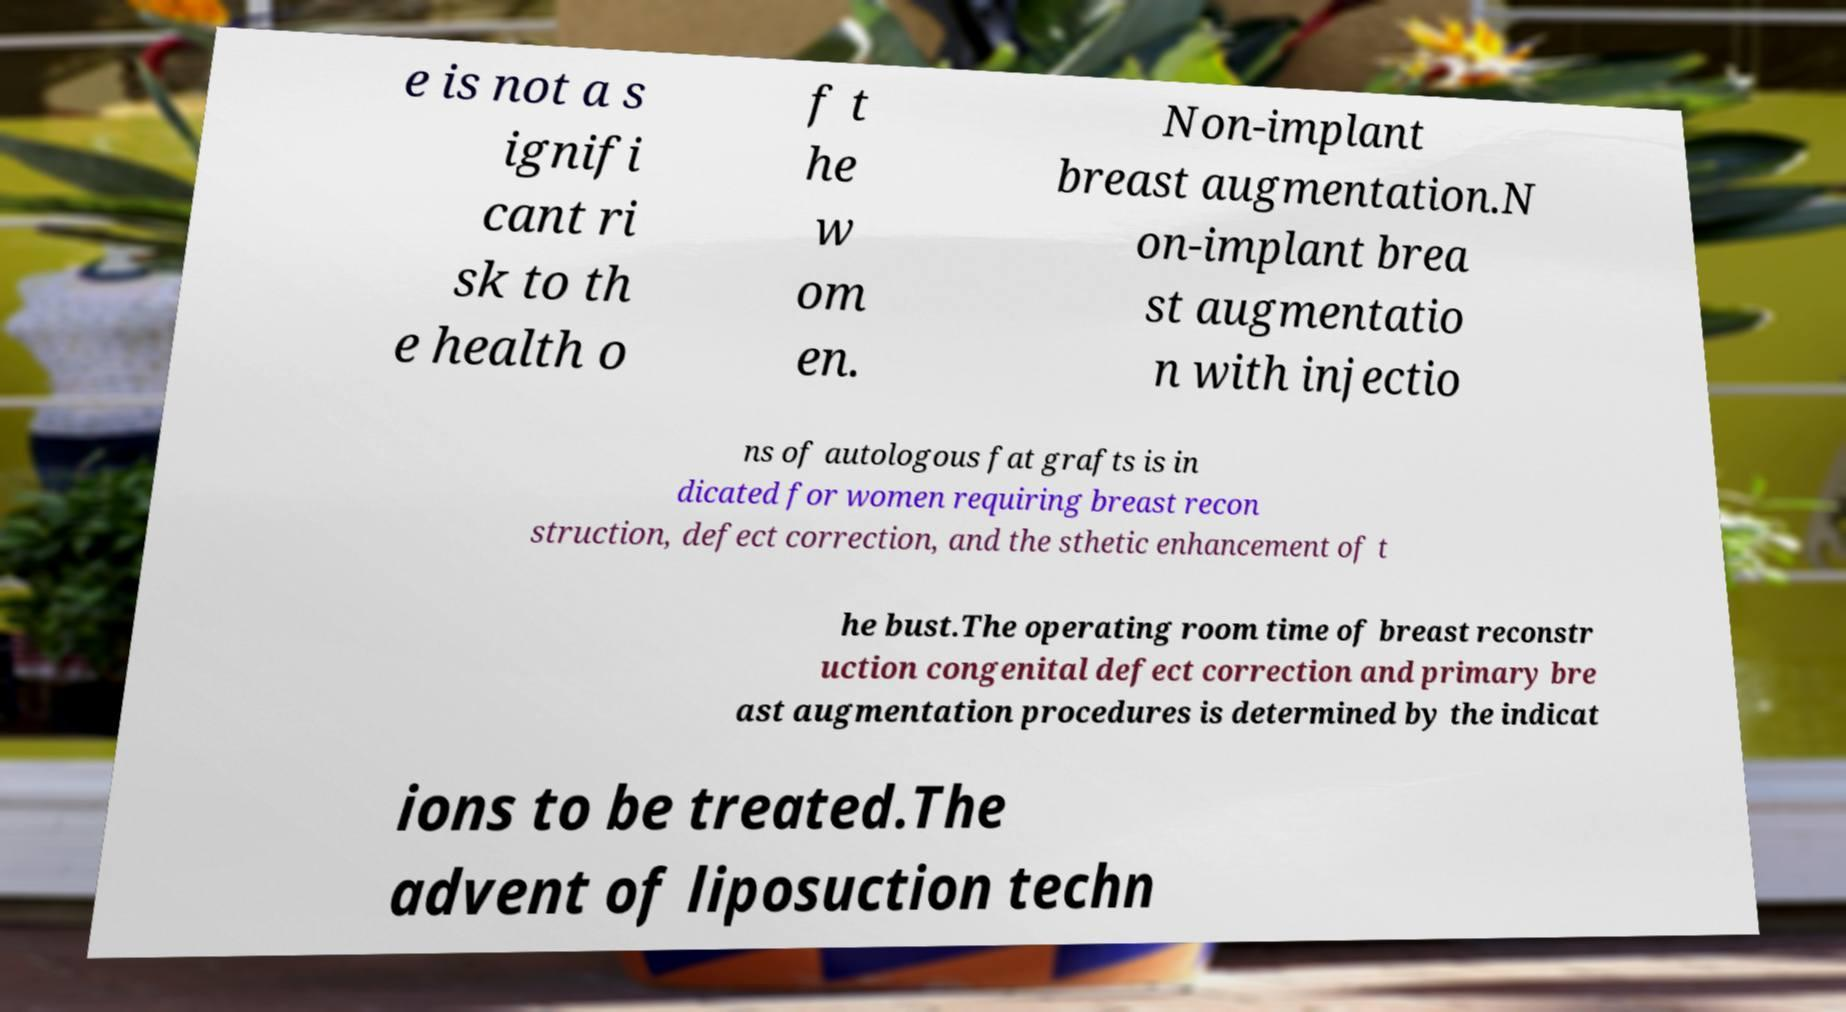What messages or text are displayed in this image? I need them in a readable, typed format. e is not a s ignifi cant ri sk to th e health o f t he w om en. Non-implant breast augmentation.N on-implant brea st augmentatio n with injectio ns of autologous fat grafts is in dicated for women requiring breast recon struction, defect correction, and the sthetic enhancement of t he bust.The operating room time of breast reconstr uction congenital defect correction and primary bre ast augmentation procedures is determined by the indicat ions to be treated.The advent of liposuction techn 